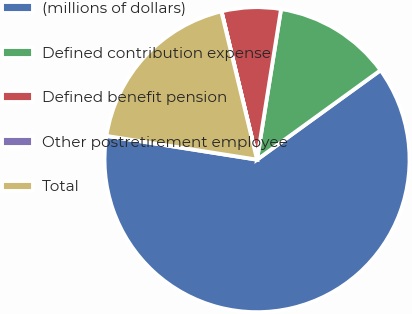Convert chart to OTSL. <chart><loc_0><loc_0><loc_500><loc_500><pie_chart><fcel>(millions of dollars)<fcel>Defined contribution expense<fcel>Defined benefit pension<fcel>Other postretirement employee<fcel>Total<nl><fcel>62.47%<fcel>12.51%<fcel>6.26%<fcel>0.02%<fcel>18.75%<nl></chart> 